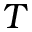Convert formula to latex. <formula><loc_0><loc_0><loc_500><loc_500>T</formula> 